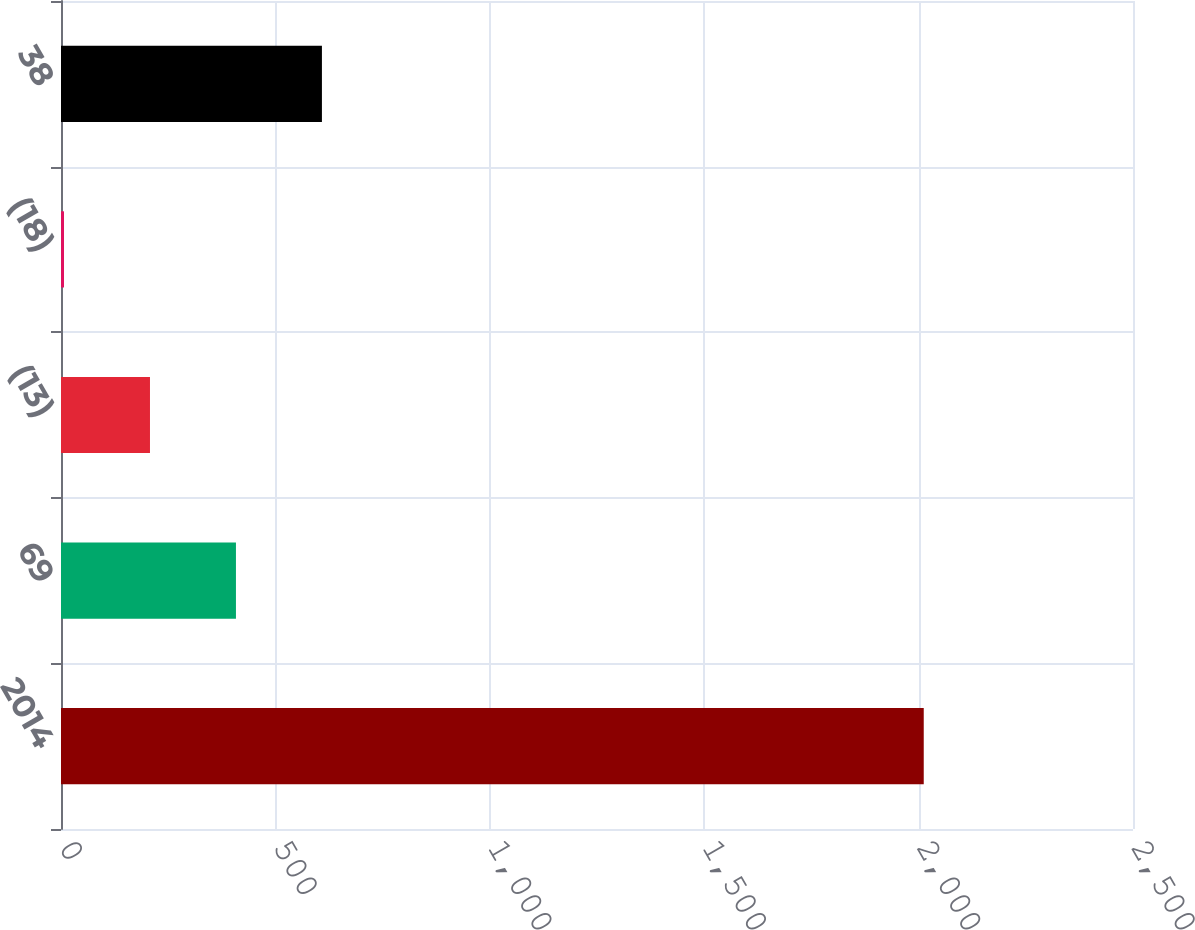Convert chart to OTSL. <chart><loc_0><loc_0><loc_500><loc_500><bar_chart><fcel>2014<fcel>69<fcel>(13)<fcel>(18)<fcel>38<nl><fcel>2012<fcel>408<fcel>207.5<fcel>7<fcel>608.5<nl></chart> 